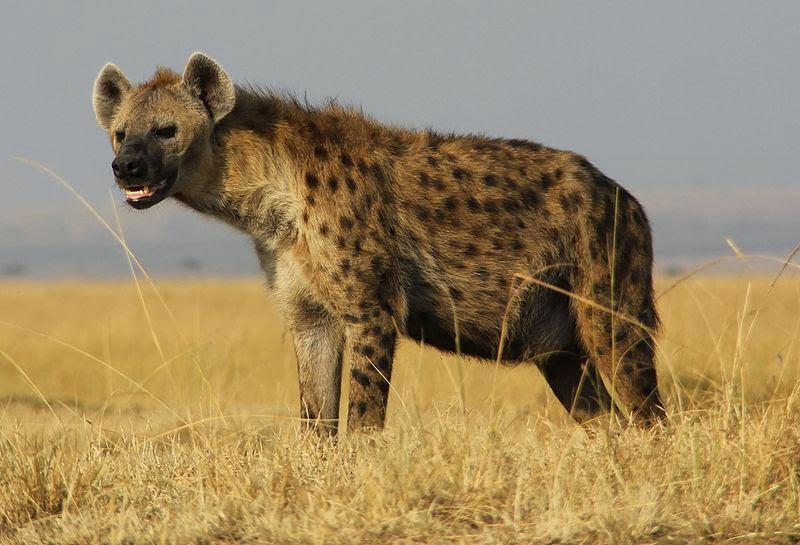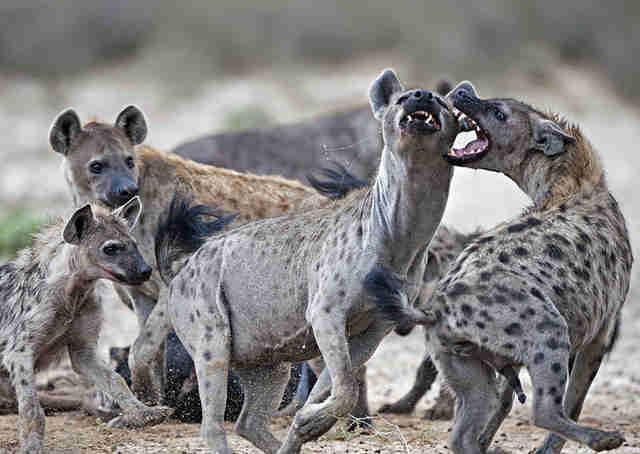The first image is the image on the left, the second image is the image on the right. Analyze the images presented: Is the assertion "One image contains at least four hyenas." valid? Answer yes or no. Yes. The first image is the image on the left, the second image is the image on the right. Considering the images on both sides, is "There are at least three spotted hyenas gathered together in the right image." valid? Answer yes or no. Yes. 